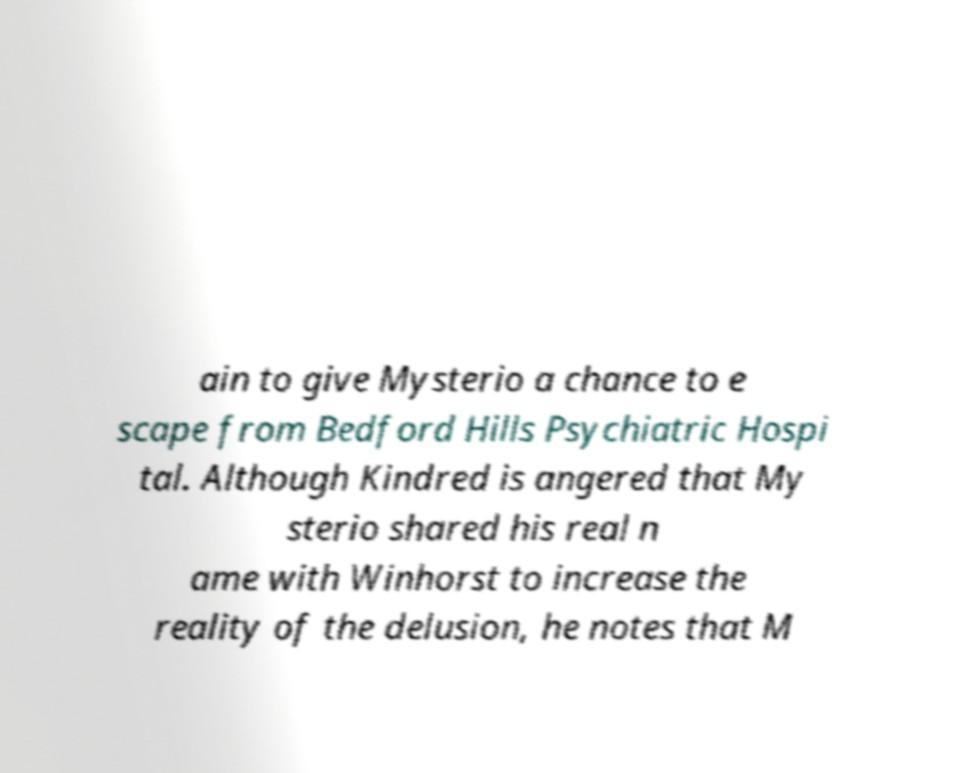Can you accurately transcribe the text from the provided image for me? ain to give Mysterio a chance to e scape from Bedford Hills Psychiatric Hospi tal. Although Kindred is angered that My sterio shared his real n ame with Winhorst to increase the reality of the delusion, he notes that M 